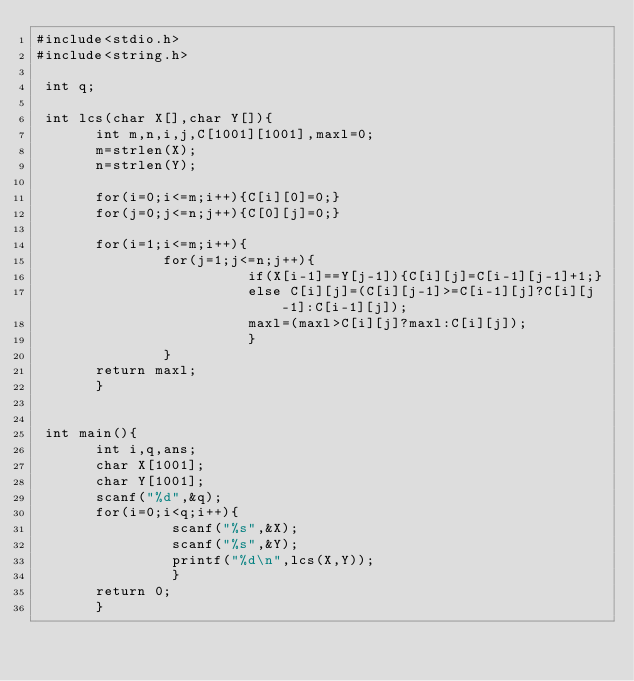Convert code to text. <code><loc_0><loc_0><loc_500><loc_500><_C_>#include<stdio.h>
#include<string.h>

 int q;

 int lcs(char X[],char Y[]){
       int m,n,i,j,C[1001][1001],maxl=0;
       m=strlen(X);
       n=strlen(Y);

       for(i=0;i<=m;i++){C[i][0]=0;}
       for(j=0;j<=n;j++){C[0][j]=0;}

       for(i=1;i<=m;i++){
               for(j=1;j<=n;j++){
                         if(X[i-1]==Y[j-1]){C[i][j]=C[i-1][j-1]+1;}
                         else C[i][j]=(C[i][j-1]>=C[i-1][j]?C[i][j-1]:C[i-1][j]);
                         maxl=(maxl>C[i][j]?maxl:C[i][j]);
                         }
               }
       return maxl;
       }
       

 int main(){
       int i,q,ans;
       char X[1001];
       char Y[1001];
       scanf("%d",&q);
       for(i=0;i<q;i++){
                scanf("%s",&X);
                scanf("%s",&Y);
                printf("%d\n",lcs(X,Y));
                }
       return 0;
       }

</code> 